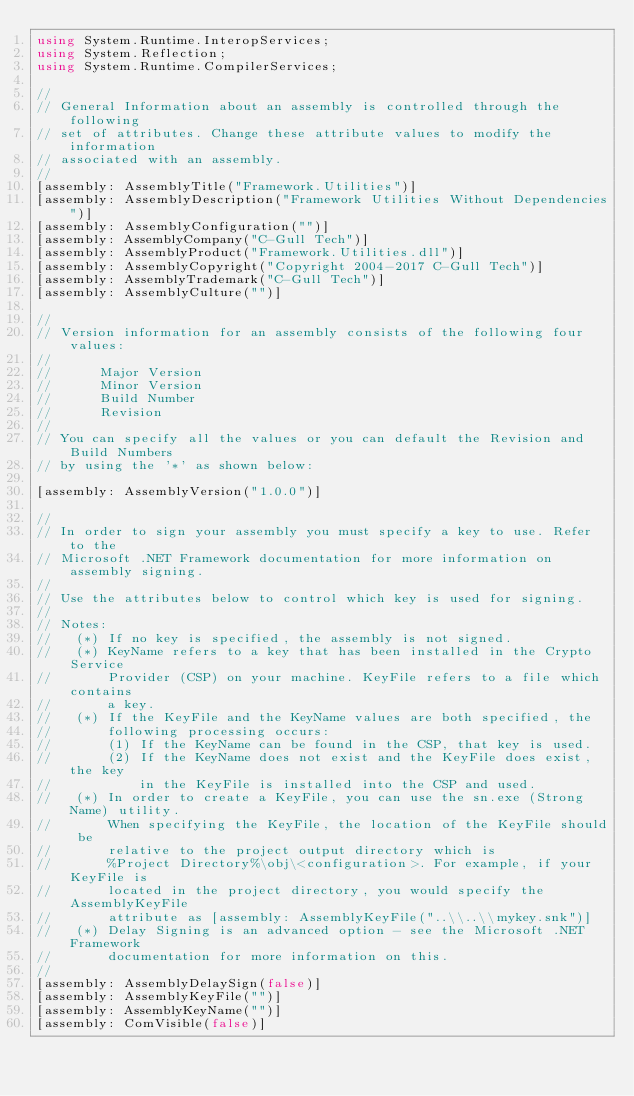Convert code to text. <code><loc_0><loc_0><loc_500><loc_500><_C#_>using System.Runtime.InteropServices;
using System.Reflection;
using System.Runtime.CompilerServices;

//
// General Information about an assembly is controlled through the following 
// set of attributes. Change these attribute values to modify the information
// associated with an assembly.
//
[assembly: AssemblyTitle("Framework.Utilities")]
[assembly: AssemblyDescription("Framework Utilities Without Dependencies")]
[assembly: AssemblyConfiguration("")]
[assembly: AssemblyCompany("C-Gull Tech")]
[assembly: AssemblyProduct("Framework.Utilities.dll")]
[assembly: AssemblyCopyright("Copyright 2004-2017 C-Gull Tech")]
[assembly: AssemblyTrademark("C-Gull Tech")]
[assembly: AssemblyCulture("")]		

//
// Version information for an assembly consists of the following four values:
//
//      Major Version
//      Minor Version 
//      Build Number
//      Revision
//
// You can specify all the values or you can default the Revision and Build Numbers 
// by using the '*' as shown below:

[assembly: AssemblyVersion("1.0.0")]

//
// In order to sign your assembly you must specify a key to use. Refer to the 
// Microsoft .NET Framework documentation for more information on assembly signing.
//
// Use the attributes below to control which key is used for signing. 
//
// Notes: 
//   (*) If no key is specified, the assembly is not signed.
//   (*) KeyName refers to a key that has been installed in the Crypto Service
//       Provider (CSP) on your machine. KeyFile refers to a file which contains
//       a key.
//   (*) If the KeyFile and the KeyName values are both specified, the 
//       following processing occurs:
//       (1) If the KeyName can be found in the CSP, that key is used.
//       (2) If the KeyName does not exist and the KeyFile does exist, the key 
//           in the KeyFile is installed into the CSP and used.
//   (*) In order to create a KeyFile, you can use the sn.exe (Strong Name) utility.
//       When specifying the KeyFile, the location of the KeyFile should be
//       relative to the project output directory which is
//       %Project Directory%\obj\<configuration>. For example, if your KeyFile is
//       located in the project directory, you would specify the AssemblyKeyFile 
//       attribute as [assembly: AssemblyKeyFile("..\\..\\mykey.snk")]
//   (*) Delay Signing is an advanced option - see the Microsoft .NET Framework
//       documentation for more information on this.
//
[assembly: AssemblyDelaySign(false)]
[assembly: AssemblyKeyFile("")]
[assembly: AssemblyKeyName("")]
[assembly: ComVisible(false)]

</code> 